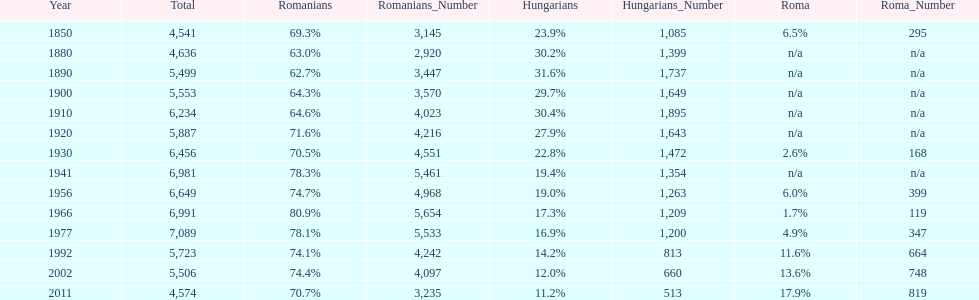Which year had the top percentage in romanian population? 1966. 